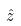<formula> <loc_0><loc_0><loc_500><loc_500>\hat { z }</formula> 